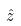<formula> <loc_0><loc_0><loc_500><loc_500>\hat { z }</formula> 